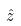<formula> <loc_0><loc_0><loc_500><loc_500>\hat { z }</formula> 